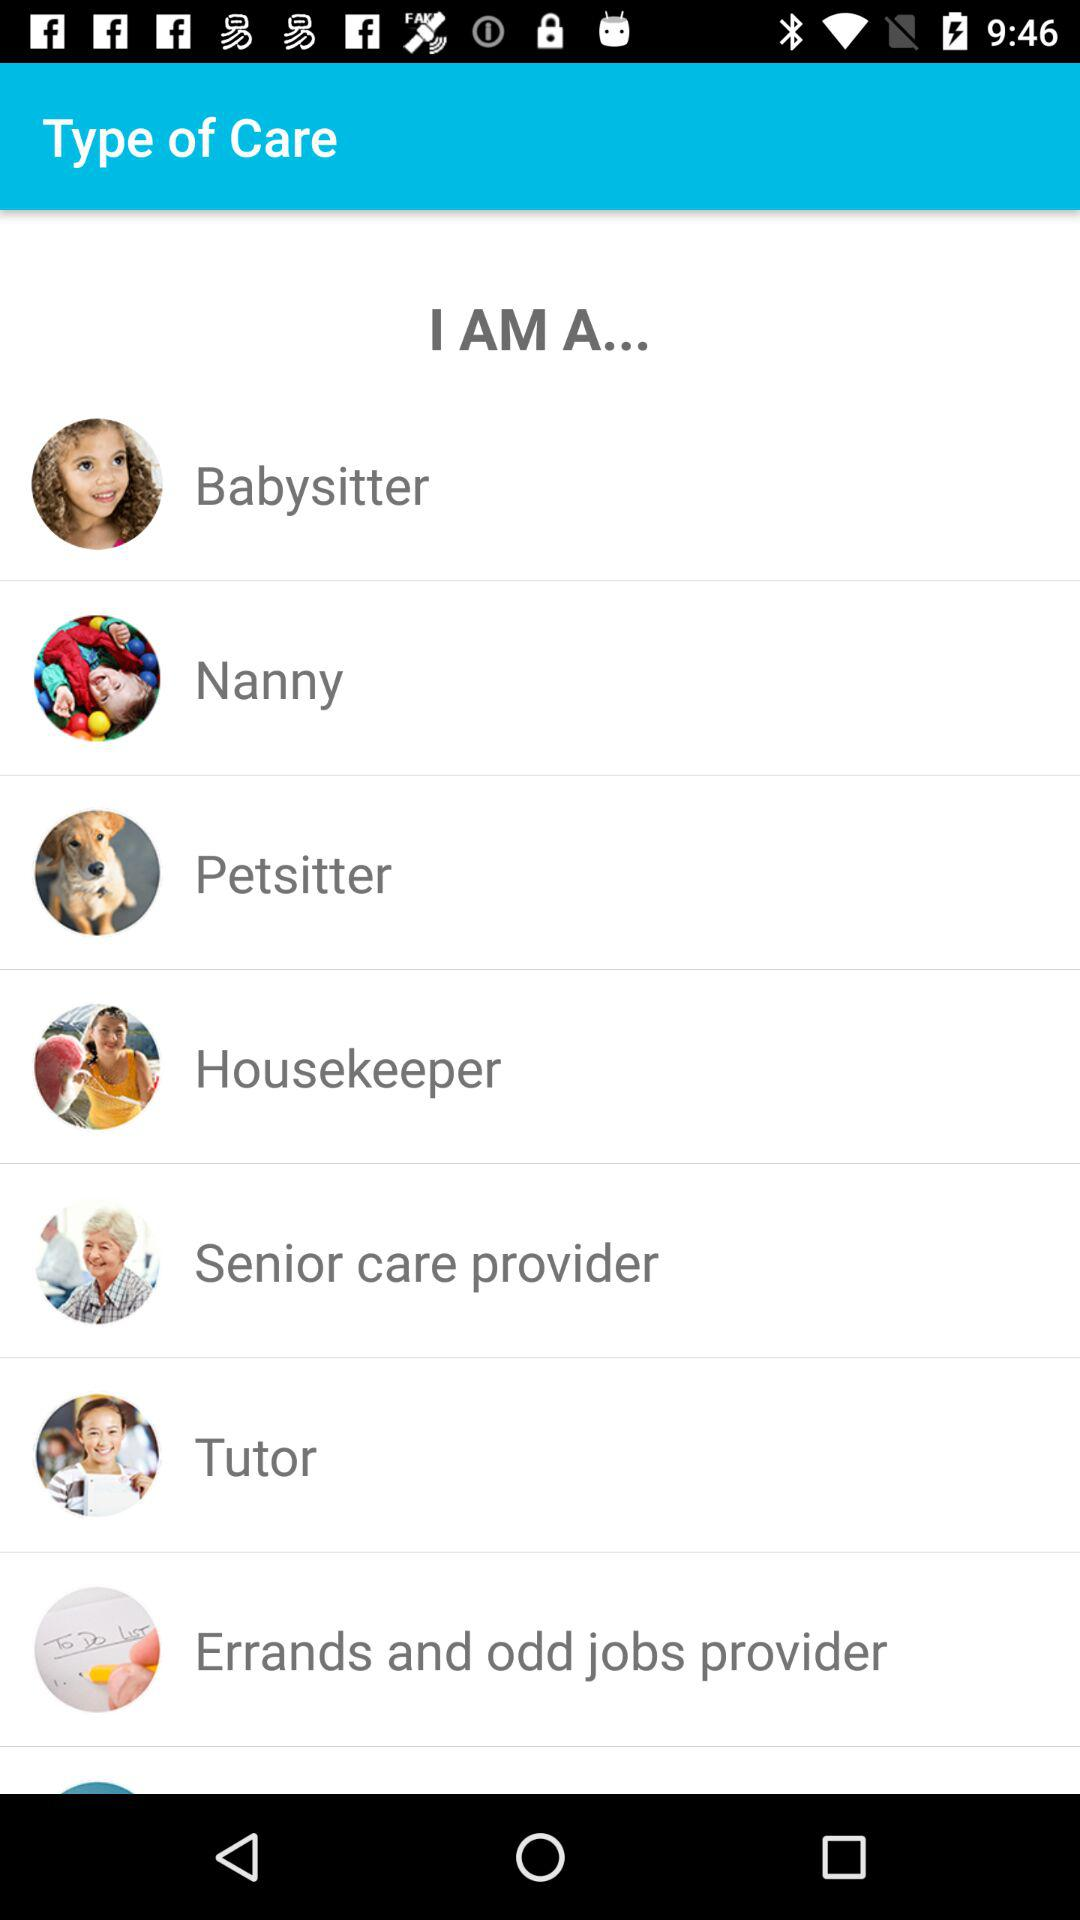How many types of care are there?
Answer the question using a single word or phrase. 7 